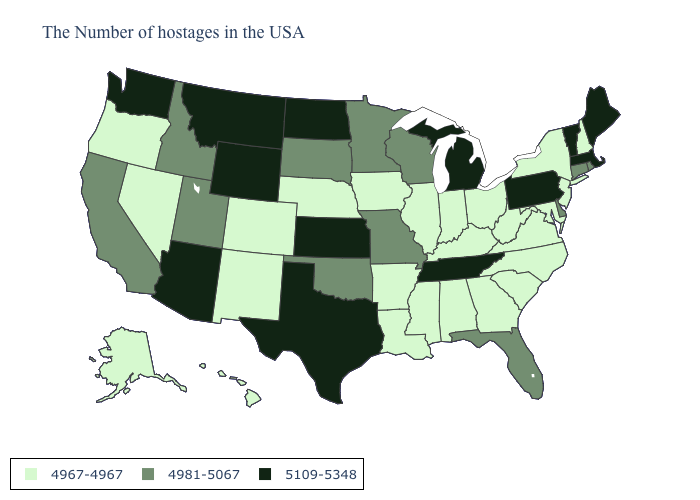Name the states that have a value in the range 5109-5348?
Short answer required. Maine, Massachusetts, Vermont, Pennsylvania, Michigan, Tennessee, Kansas, Texas, North Dakota, Wyoming, Montana, Arizona, Washington. Among the states that border Michigan , which have the highest value?
Short answer required. Wisconsin. Among the states that border West Virginia , does Pennsylvania have the highest value?
Quick response, please. Yes. Name the states that have a value in the range 4967-4967?
Give a very brief answer. New Hampshire, New York, New Jersey, Maryland, Virginia, North Carolina, South Carolina, West Virginia, Ohio, Georgia, Kentucky, Indiana, Alabama, Illinois, Mississippi, Louisiana, Arkansas, Iowa, Nebraska, Colorado, New Mexico, Nevada, Oregon, Alaska, Hawaii. What is the value of Alaska?
Keep it brief. 4967-4967. Which states have the lowest value in the South?
Short answer required. Maryland, Virginia, North Carolina, South Carolina, West Virginia, Georgia, Kentucky, Alabama, Mississippi, Louisiana, Arkansas. What is the lowest value in the MidWest?
Be succinct. 4967-4967. What is the value of Tennessee?
Keep it brief. 5109-5348. Does Indiana have the highest value in the USA?
Write a very short answer. No. What is the lowest value in the South?
Short answer required. 4967-4967. Name the states that have a value in the range 4981-5067?
Give a very brief answer. Rhode Island, Connecticut, Delaware, Florida, Wisconsin, Missouri, Minnesota, Oklahoma, South Dakota, Utah, Idaho, California. Does Missouri have a lower value than Vermont?
Give a very brief answer. Yes. Which states hav the highest value in the MidWest?
Concise answer only. Michigan, Kansas, North Dakota. What is the value of Colorado?
Be succinct. 4967-4967. 